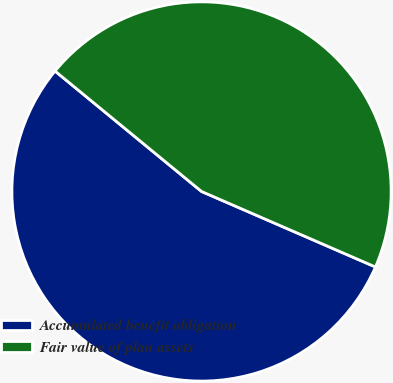<chart> <loc_0><loc_0><loc_500><loc_500><pie_chart><fcel>Accumulated benefit obligation<fcel>Fair value of plan assets<nl><fcel>54.43%<fcel>45.57%<nl></chart> 